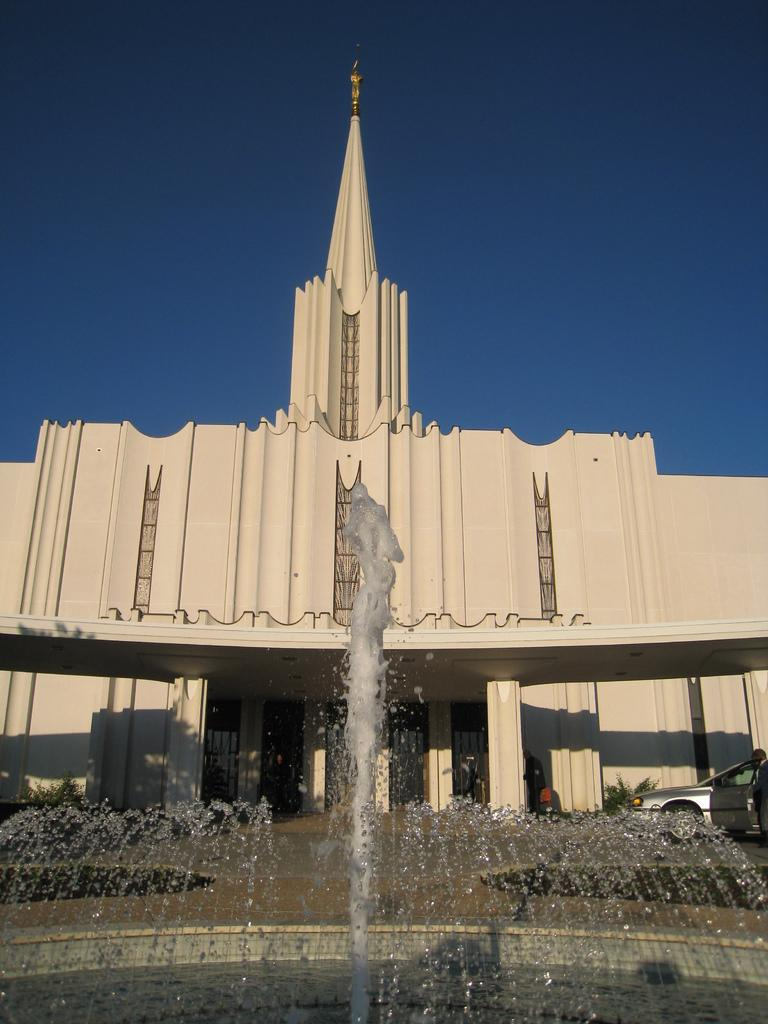What type of structure is visible in the image? There is a building in the image. What mode of transportation can be seen in the image? There is a car in the image. Can you describe the person in the image? There is a person standing on the ground in the image. What type of feature is present in the image for people to use? There is a water fountain in the image. What type of natural elements are present in the image? There are plants in the image. Are there any other objects visible in the image? Yes, there are other objects in the image. What can be seen in the background of the image? The sky is visible in the background of the image. How does the person in the image express their feeling towards the rodent? There is no rodent present in the image, and therefore no interaction or expression of feelings can be observed. 